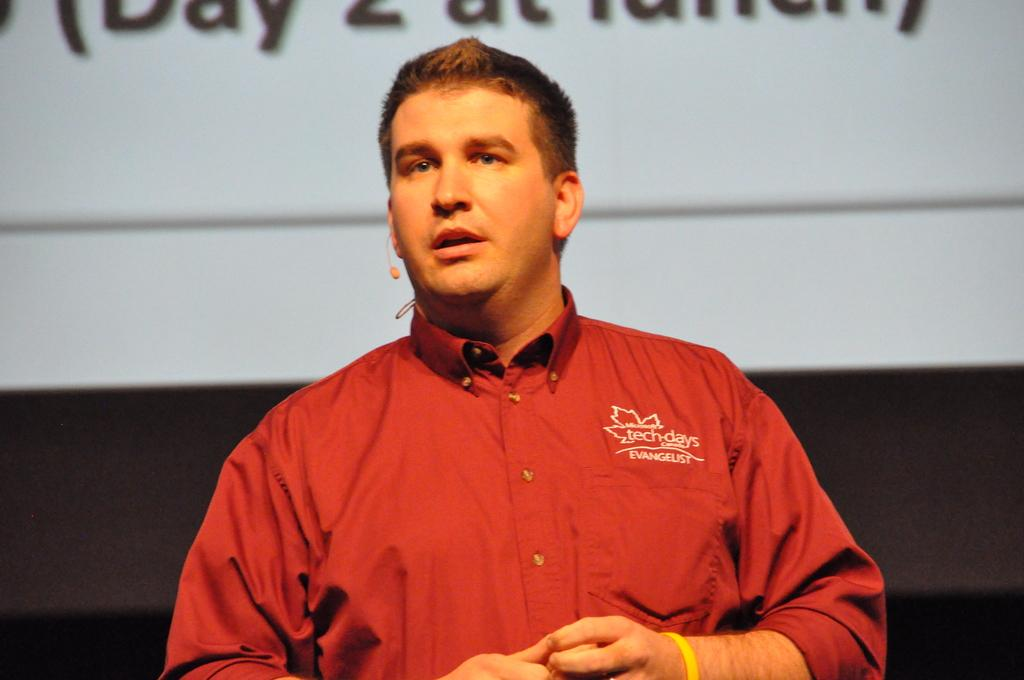What is the main subject of the image? There is a person in the image. What is the person wearing? The person is wearing a microphone. What is the person doing in the image? The person is delivering a speech. What can be seen behind the person? There is a screen behind the person. What type of class is being taught in the image? There is no class or teaching activity depicted in the image; it features a person delivering a speech. Can you see any zippers on the person's clothing in the image? The provided facts do not mention any zippers on the person's clothing, so it cannot be determined from the image. 